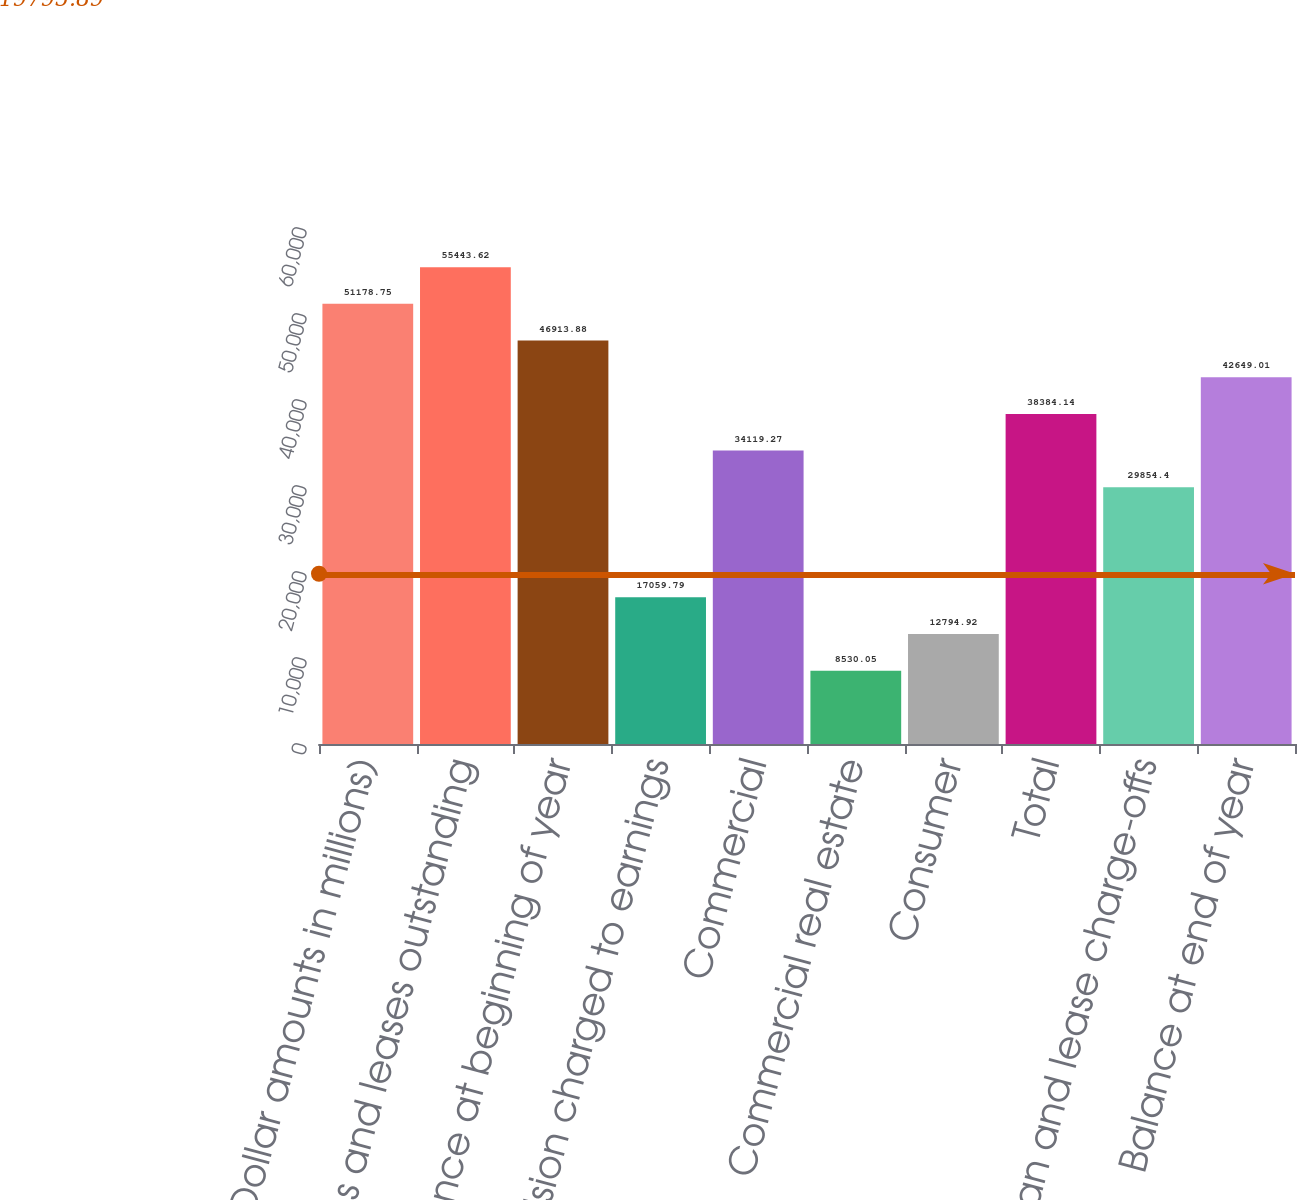<chart> <loc_0><loc_0><loc_500><loc_500><bar_chart><fcel>(Dollar amounts in millions)<fcel>Loans and leases outstanding<fcel>Balance at beginning of year<fcel>Provision charged to earnings<fcel>Commercial<fcel>Commercial real estate<fcel>Consumer<fcel>Total<fcel>Net loan and lease charge-offs<fcel>Balance at end of year<nl><fcel>51178.8<fcel>55443.6<fcel>46913.9<fcel>17059.8<fcel>34119.3<fcel>8530.05<fcel>12794.9<fcel>38384.1<fcel>29854.4<fcel>42649<nl></chart> 